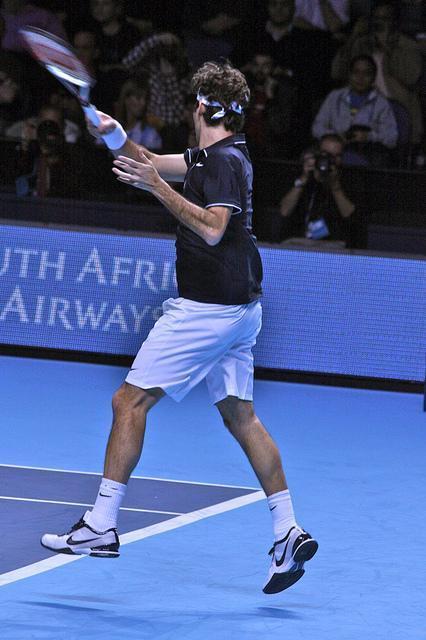How many people can be seen?
Give a very brief answer. 10. 